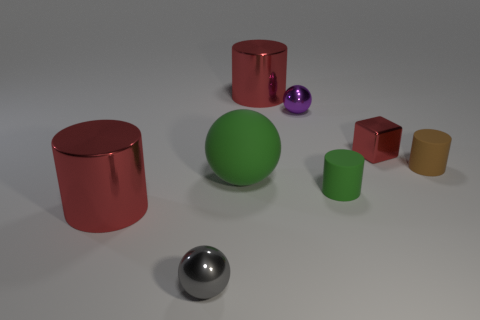The brown rubber thing is what size?
Make the answer very short. Small. Is the large green thing made of the same material as the red cube?
Offer a terse response. No. What number of big green spheres are in front of the large object that is right of the green matte thing that is behind the tiny green rubber cylinder?
Offer a very short reply. 1. There is a big green thing that is behind the gray ball; what shape is it?
Keep it short and to the point. Sphere. How many other things are there of the same material as the tiny green object?
Keep it short and to the point. 2. Are there fewer tiny green matte cylinders that are behind the small purple sphere than small gray objects that are right of the tiny red thing?
Your answer should be compact. No. There is another metal thing that is the same shape as the tiny gray metal object; what is its color?
Keep it short and to the point. Purple. There is a red block to the left of the brown cylinder; is it the same size as the purple thing?
Your response must be concise. Yes. Is the number of tiny brown matte cylinders that are on the left side of the small green cylinder less than the number of brown rubber cylinders?
Your answer should be very brief. Yes. There is a rubber object that is left of the small sphere behind the tiny block; what size is it?
Provide a succinct answer. Large. 